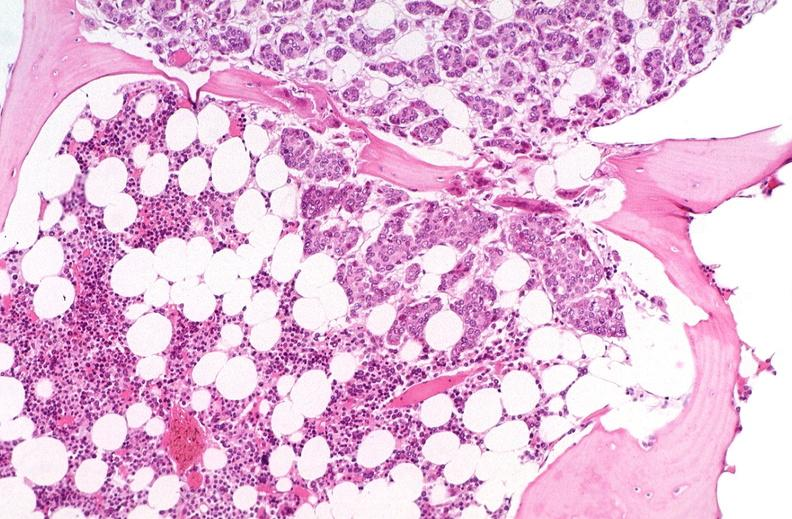s this section present?
Answer the question using a single word or phrase. No 